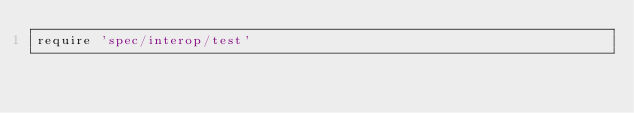<code> <loc_0><loc_0><loc_500><loc_500><_Ruby_>require 'spec/interop/test'</code> 